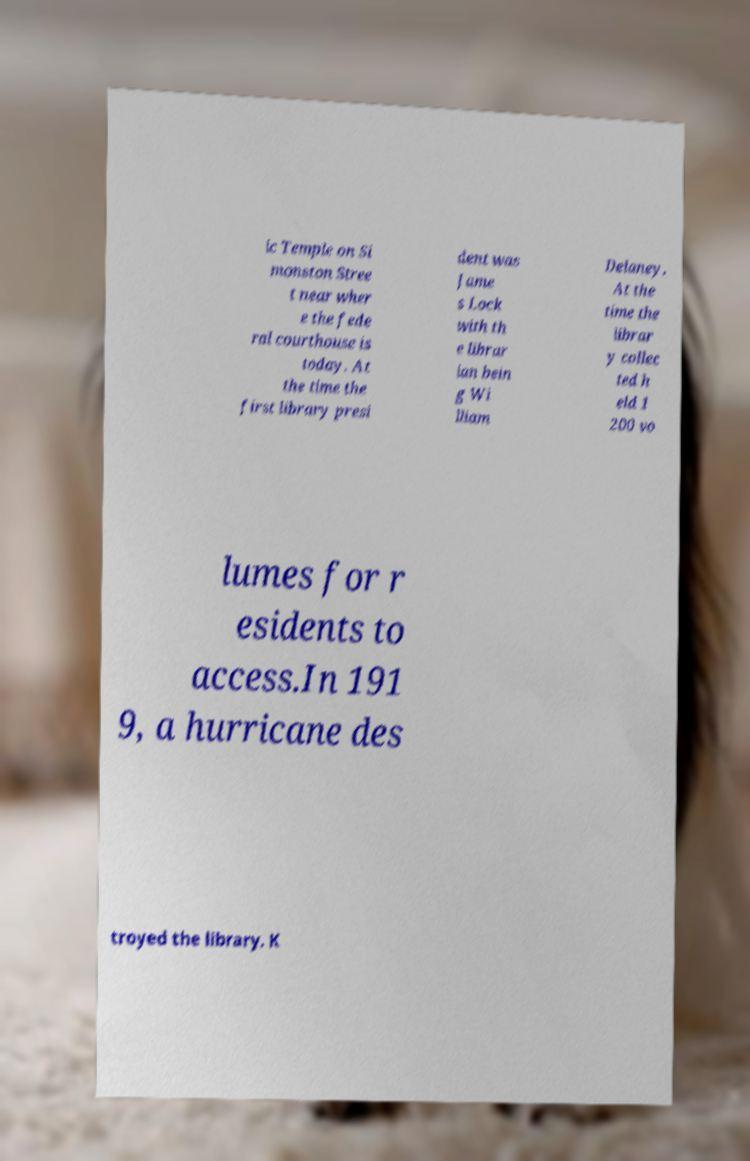Could you extract and type out the text from this image? ic Temple on Si monston Stree t near wher e the fede ral courthouse is today. At the time the first library presi dent was Jame s Lock with th e librar ian bein g Wi lliam Delaney. At the time the librar y collec ted h eld 1 200 vo lumes for r esidents to access.In 191 9, a hurricane des troyed the library. K 